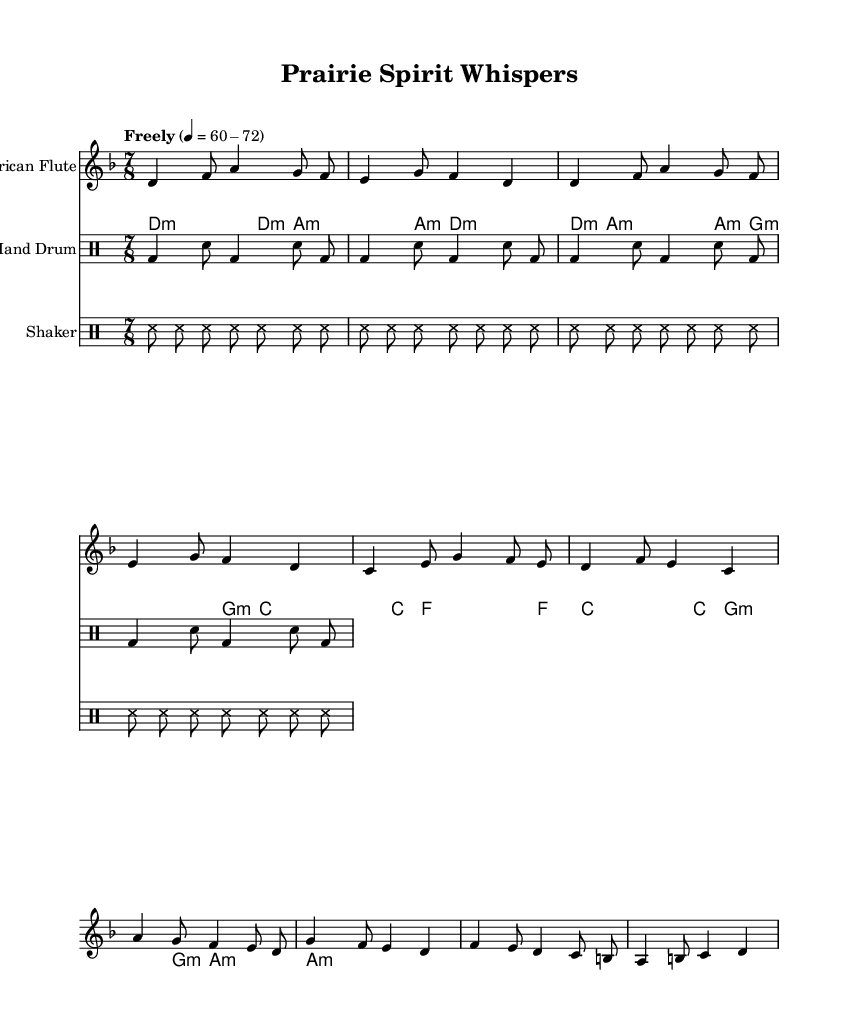What is the key signature of this music? The key signature is indicated by the "d" in the global section, which shows that this piece is in D minor.
Answer: D minor What is the time signature of this music? The time signature is shown as "7/8" in the global section, meaning there are seven eighth notes per measure.
Answer: 7/8 What is the tempo marking for this piece? The tempo marking is "Freely" with a metronome mark of 60-72 beats per minute, which indicates a flexible tempo primarily within that range.
Answer: Freely 60-72 How many measures are in the verse section? The verse consists of four measures, as indicated by the repetition of the musical phrases in that section.
Answer: 4 What instruments are utilized in this composition? The piece features a Native American flute, acoustic guitar, hand drum, and shaker, as indicated by the different staves in the score.
Answer: Native American flute, acoustic guitar, hand drum, shaker What is the rhythmic pattern of the hand drum? The hand drum follows a basic pattern consisting of alternating bass and snare hits, repeated four times, which establishes a rhythmic foundation.
Answer: Bass and snare pattern What type of fusion is represented in this piece? This piece incorporates elements of experimental folk fusion with traditional Indigenous instruments, highlighting a blending of styles and cultural sounds.
Answer: Experimental folk fusion 